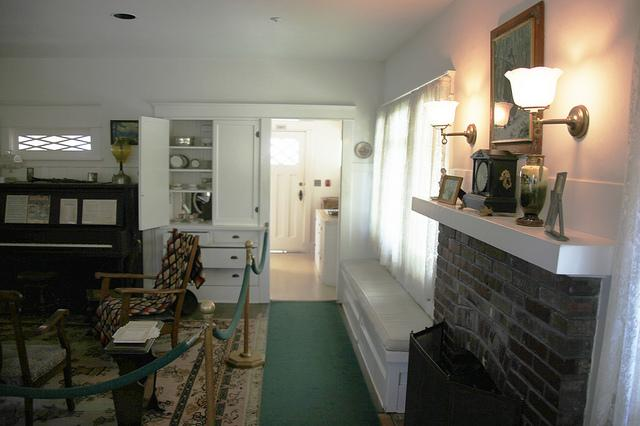What item is under the bright lights attached to the wall?

Choices:
A) oven
B) washing machine
C) fireplace
D) cat fireplace 